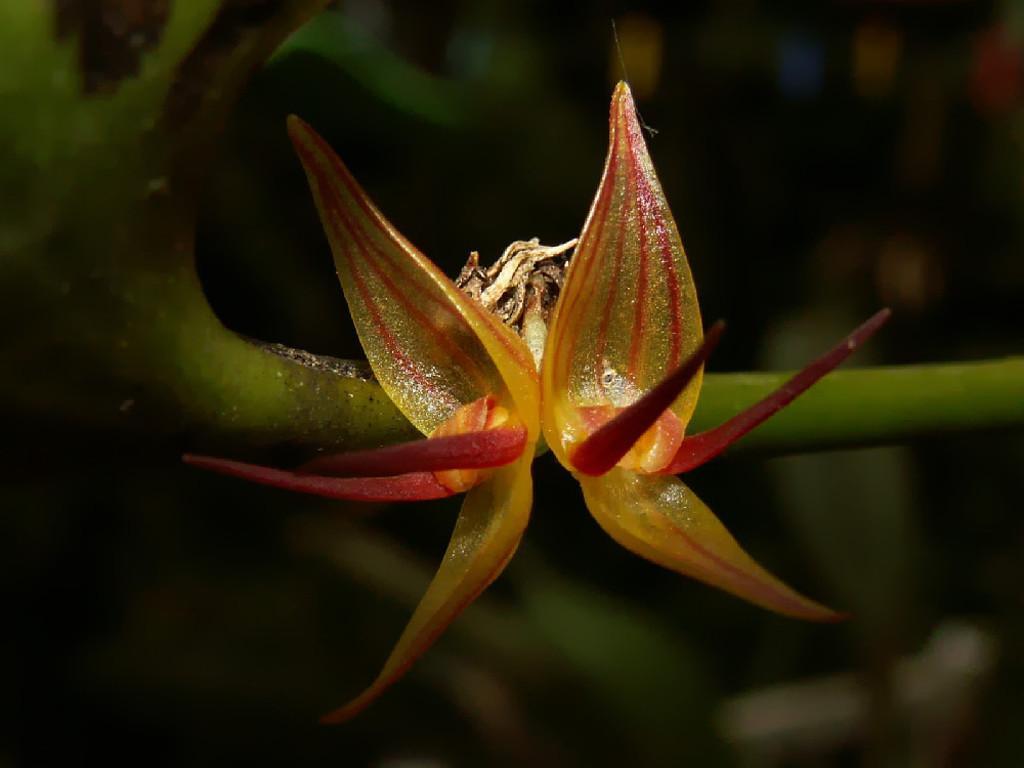Describe this image in one or two sentences. In this picture we can see a flower on a stem and in the background we can see it is dark. 